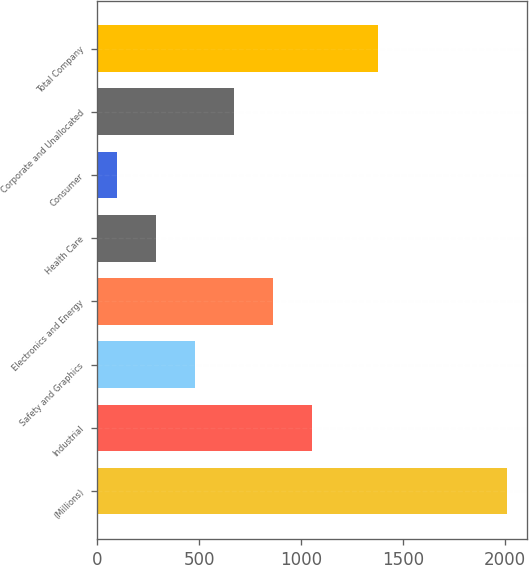Convert chart. <chart><loc_0><loc_0><loc_500><loc_500><bar_chart><fcel>(Millions)<fcel>Industrial<fcel>Safety and Graphics<fcel>Electronics and Energy<fcel>Health Care<fcel>Consumer<fcel>Corporate and Unallocated<fcel>Total Company<nl><fcel>2011<fcel>1054.5<fcel>480.6<fcel>863.2<fcel>289.3<fcel>98<fcel>671.9<fcel>1379<nl></chart> 